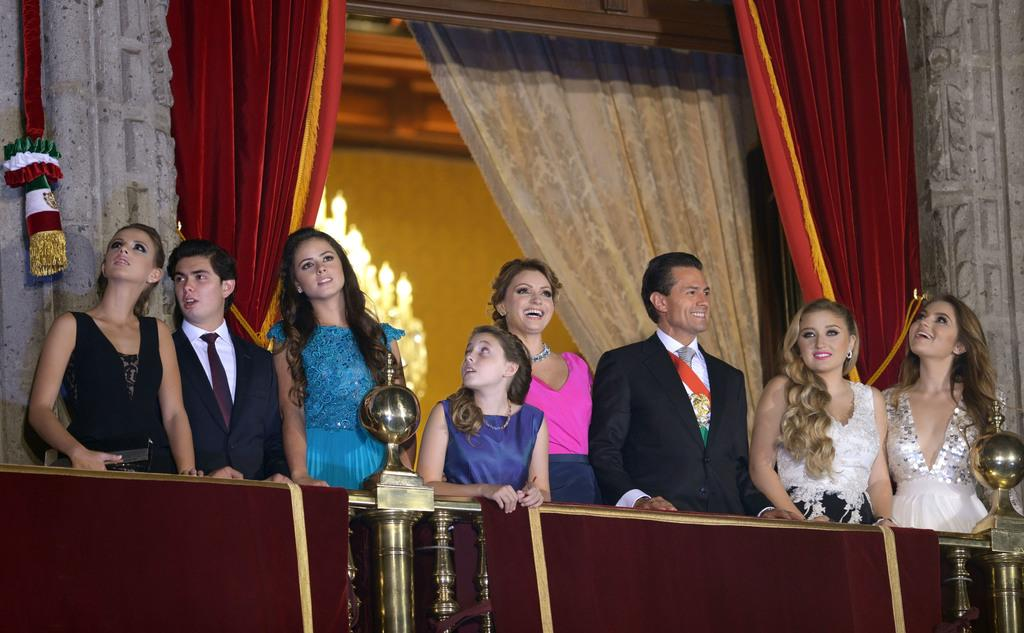How many people are present in the image? There are many people standing in the image. What are the people wearing? The people are wearing clothes. Can you describe the expressions on some of the people's faces? Some of the people are smiling. What type of barrier can be seen in the image? There is a fence visible in the image. What can be used to provide illumination in the image? There are lights in the image. What type of window treatment is present in the image? There are curtains in the image. Can you tell me how many trees are visible in the image? There are no trees visible in the image. What type of offer is being made by the people in the image? There is no offer being made by the people in the image; they are simply standing. 